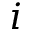Convert formula to latex. <formula><loc_0><loc_0><loc_500><loc_500>i</formula> 